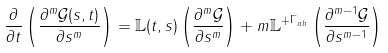Convert formula to latex. <formula><loc_0><loc_0><loc_500><loc_500>\frac { \partial } { \partial t } \left ( \frac { \partial ^ { m } \mathcal { G } ( s , t ) } { \partial s ^ { m } } \right ) = \mathbb { L } ( t , s ) \left ( \frac { \partial ^ { m } \mathcal { G } } { \partial s ^ { m } } \right ) + m \mathbb { L } ^ { + \Gamma _ { a b } } \left ( \frac { \partial ^ { m - 1 } \mathcal { G } } { \partial s ^ { m - 1 } } \right )</formula> 